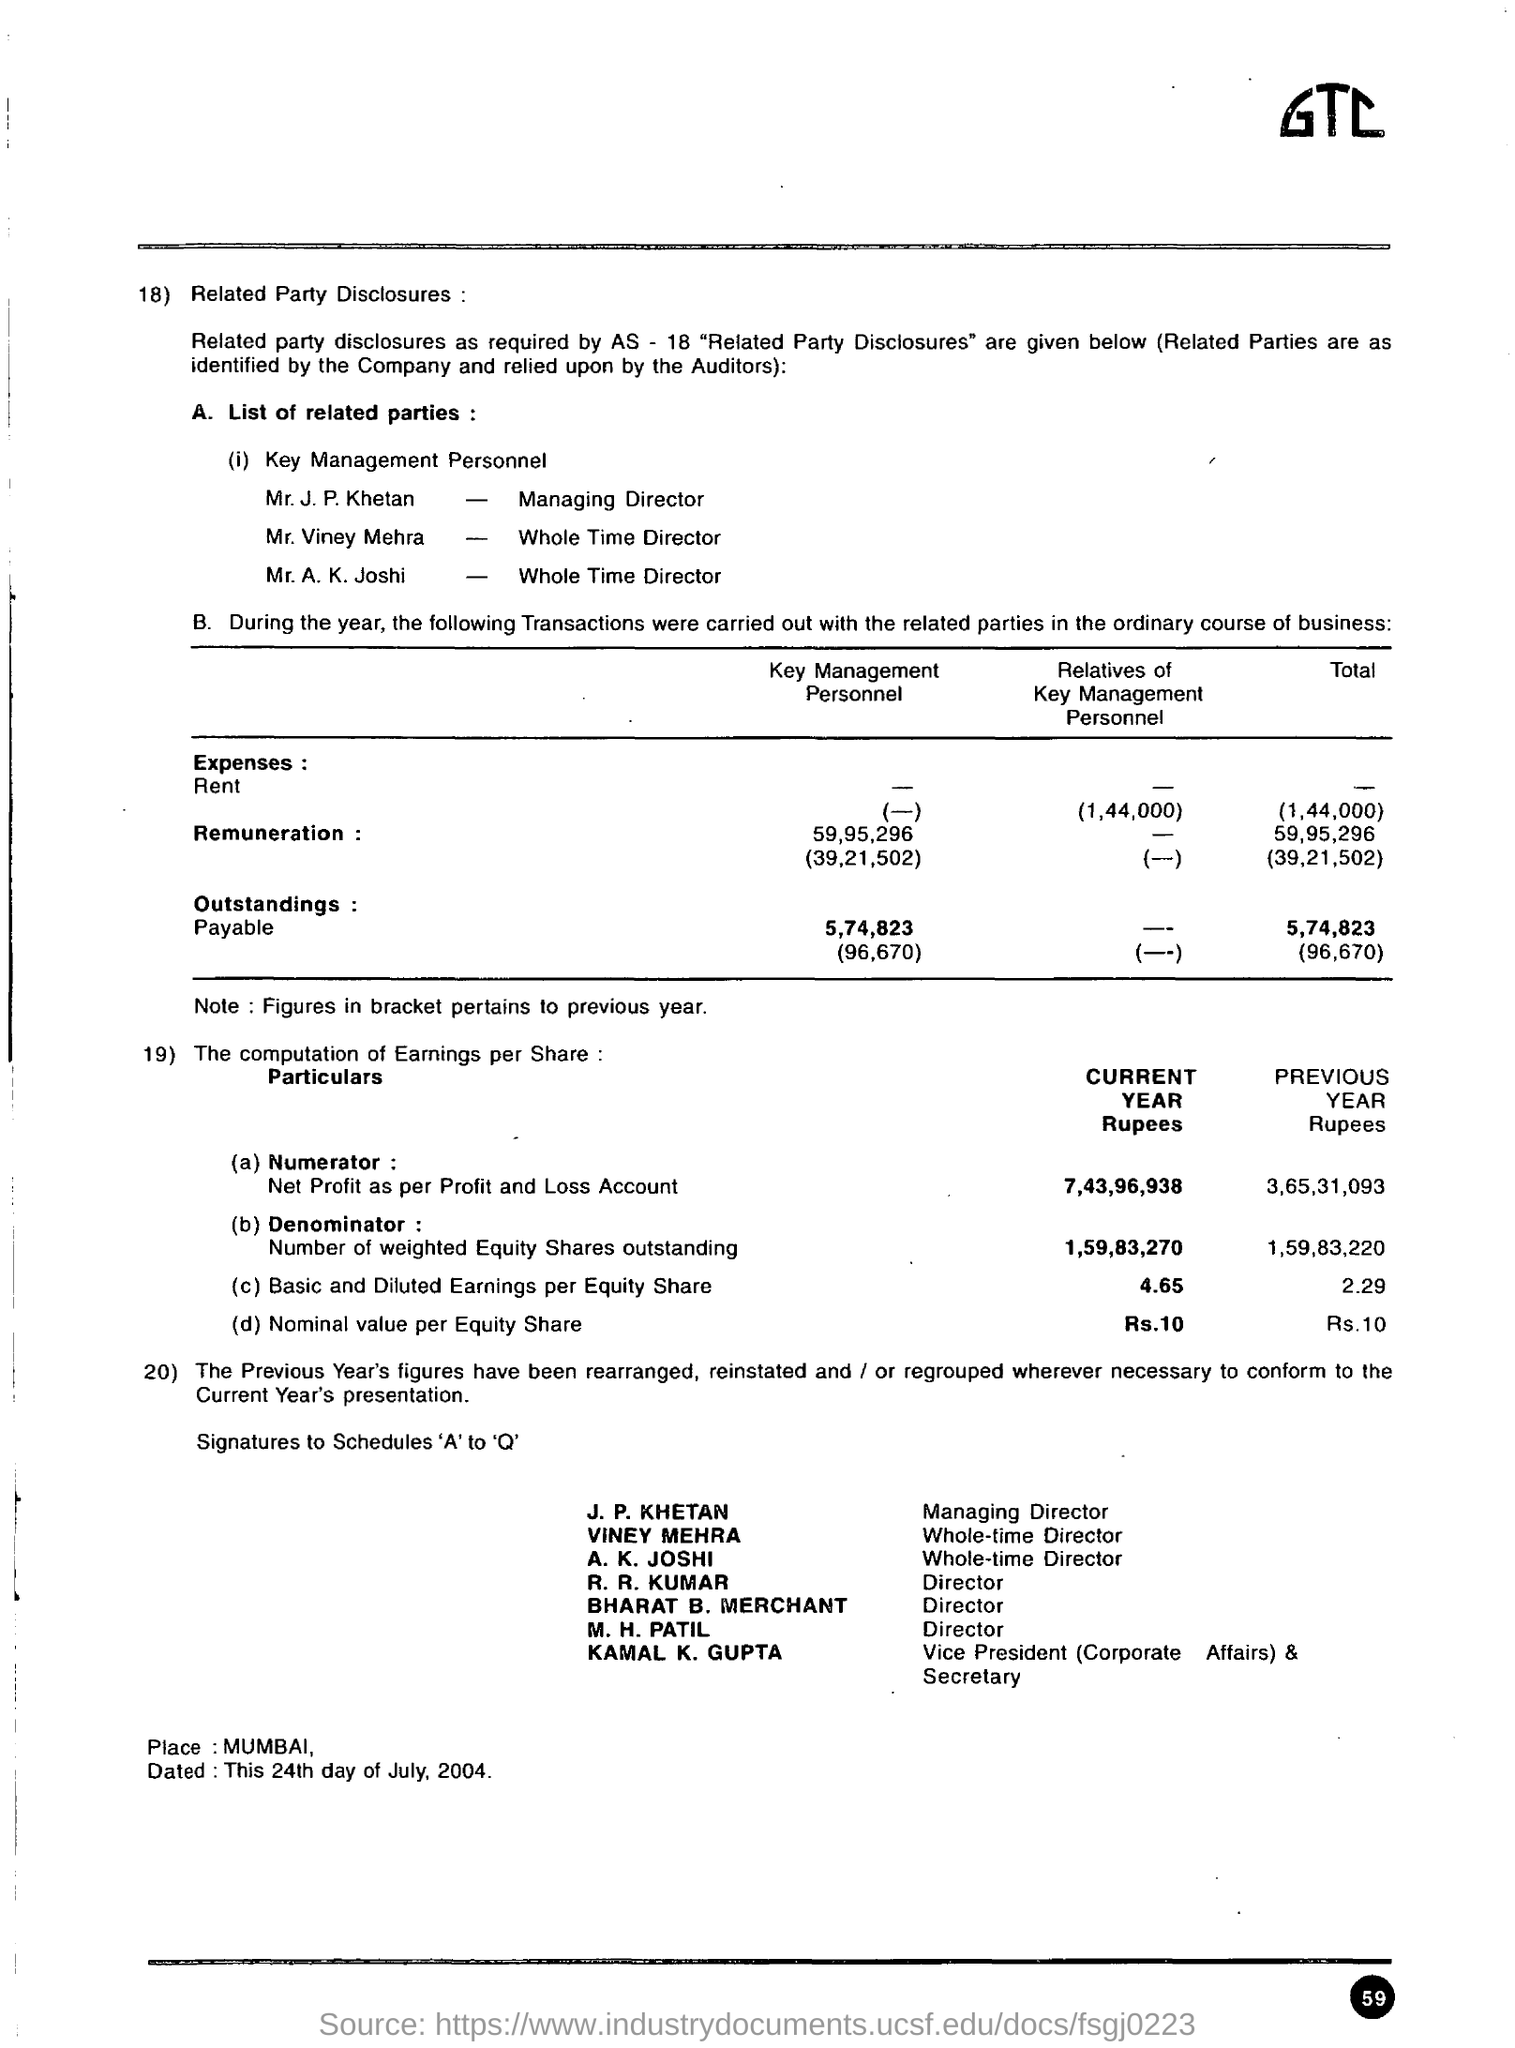What is the amount  of nominal value per equity share in the current year ?
Offer a very short reply. 10. What is the amount of basic and diluted earnings per equity share in the current year ?
Make the answer very short. 4.65. What is the place mentioned in the given disclosure ?
Make the answer very short. Mumbai. What is the amount of basic and diluted earnings per equity share in the previous year ?
Offer a terse response. 2.29. 